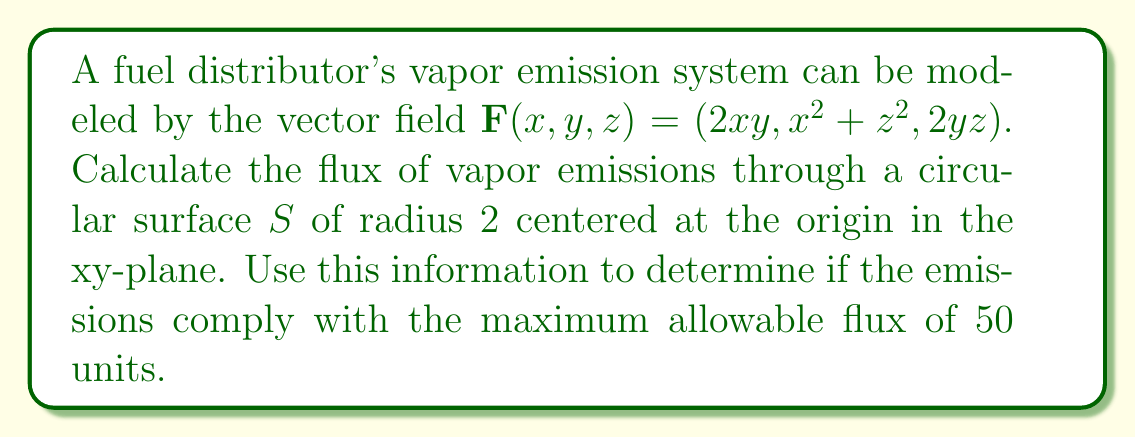Help me with this question. To solve this problem, we'll follow these steps:

1) The flux of a vector field through a surface is given by the surface integral:

   $\iint_S \mathbf{F} \cdot \mathbf{n} \, dS$

   where $\mathbf{n}$ is the unit normal vector to the surface.

2) For our circular surface in the xy-plane, $\mathbf{n} = (0,0,1)$.

3) We can parameterize the circular surface using polar coordinates:
   
   $x = r\cos\theta$, $y = r\sin\theta$, $z = 0$
   
   where $0 \leq r \leq 2$ and $0 \leq \theta \leq 2\pi$

4) The vector field on the surface becomes:

   $\mathbf{F}(r\cos\theta, r\sin\theta, 0) = (2r^2\cos\theta\sin\theta, r^2\cos^2\theta, 0)$

5) The dot product $\mathbf{F} \cdot \mathbf{n}$ is simply the z-component of $\mathbf{F}$, which is 0.

6) Therefore, the flux integral becomes:

   $\iint_S 0 \, dS = 0$

7) The calculated flux (0) is less than the maximum allowable flux (50), so the emissions comply with regulations.
Answer: 0 (compliant) 